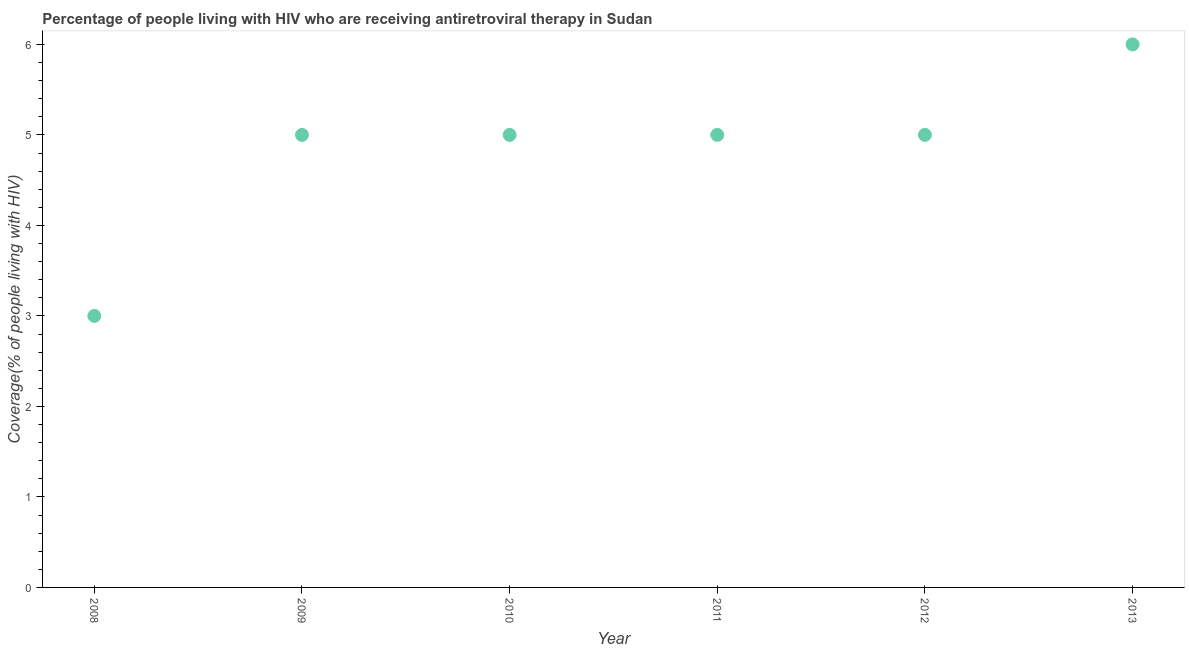What is the antiretroviral therapy coverage in 2012?
Provide a short and direct response. 5. Across all years, what is the minimum antiretroviral therapy coverage?
Provide a succinct answer. 3. In which year was the antiretroviral therapy coverage maximum?
Your response must be concise. 2013. What is the sum of the antiretroviral therapy coverage?
Ensure brevity in your answer.  29. What is the difference between the antiretroviral therapy coverage in 2008 and 2009?
Offer a terse response. -2. What is the average antiretroviral therapy coverage per year?
Keep it short and to the point. 4.83. What is the median antiretroviral therapy coverage?
Keep it short and to the point. 5. What is the ratio of the antiretroviral therapy coverage in 2008 to that in 2010?
Your answer should be compact. 0.6. Is the difference between the antiretroviral therapy coverage in 2011 and 2013 greater than the difference between any two years?
Give a very brief answer. No. What is the difference between the highest and the second highest antiretroviral therapy coverage?
Offer a very short reply. 1. Is the sum of the antiretroviral therapy coverage in 2012 and 2013 greater than the maximum antiretroviral therapy coverage across all years?
Offer a terse response. Yes. What is the difference between the highest and the lowest antiretroviral therapy coverage?
Offer a very short reply. 3. In how many years, is the antiretroviral therapy coverage greater than the average antiretroviral therapy coverage taken over all years?
Provide a short and direct response. 5. Does the antiretroviral therapy coverage monotonically increase over the years?
Keep it short and to the point. No. Are the values on the major ticks of Y-axis written in scientific E-notation?
Offer a very short reply. No. Does the graph contain any zero values?
Ensure brevity in your answer.  No. What is the title of the graph?
Your response must be concise. Percentage of people living with HIV who are receiving antiretroviral therapy in Sudan. What is the label or title of the Y-axis?
Offer a terse response. Coverage(% of people living with HIV). What is the Coverage(% of people living with HIV) in 2008?
Give a very brief answer. 3. What is the Coverage(% of people living with HIV) in 2010?
Offer a terse response. 5. What is the Coverage(% of people living with HIV) in 2012?
Keep it short and to the point. 5. What is the difference between the Coverage(% of people living with HIV) in 2008 and 2010?
Provide a short and direct response. -2. What is the difference between the Coverage(% of people living with HIV) in 2008 and 2013?
Provide a succinct answer. -3. What is the difference between the Coverage(% of people living with HIV) in 2009 and 2010?
Ensure brevity in your answer.  0. What is the difference between the Coverage(% of people living with HIV) in 2009 and 2012?
Offer a terse response. 0. What is the difference between the Coverage(% of people living with HIV) in 2009 and 2013?
Ensure brevity in your answer.  -1. What is the difference between the Coverage(% of people living with HIV) in 2010 and 2011?
Offer a very short reply. 0. What is the difference between the Coverage(% of people living with HIV) in 2010 and 2013?
Make the answer very short. -1. What is the difference between the Coverage(% of people living with HIV) in 2011 and 2012?
Ensure brevity in your answer.  0. What is the difference between the Coverage(% of people living with HIV) in 2011 and 2013?
Provide a short and direct response. -1. What is the difference between the Coverage(% of people living with HIV) in 2012 and 2013?
Offer a very short reply. -1. What is the ratio of the Coverage(% of people living with HIV) in 2008 to that in 2010?
Provide a short and direct response. 0.6. What is the ratio of the Coverage(% of people living with HIV) in 2008 to that in 2013?
Provide a succinct answer. 0.5. What is the ratio of the Coverage(% of people living with HIV) in 2009 to that in 2010?
Keep it short and to the point. 1. What is the ratio of the Coverage(% of people living with HIV) in 2009 to that in 2013?
Your answer should be very brief. 0.83. What is the ratio of the Coverage(% of people living with HIV) in 2010 to that in 2011?
Keep it short and to the point. 1. What is the ratio of the Coverage(% of people living with HIV) in 2010 to that in 2013?
Make the answer very short. 0.83. What is the ratio of the Coverage(% of people living with HIV) in 2011 to that in 2013?
Offer a terse response. 0.83. What is the ratio of the Coverage(% of people living with HIV) in 2012 to that in 2013?
Your answer should be very brief. 0.83. 